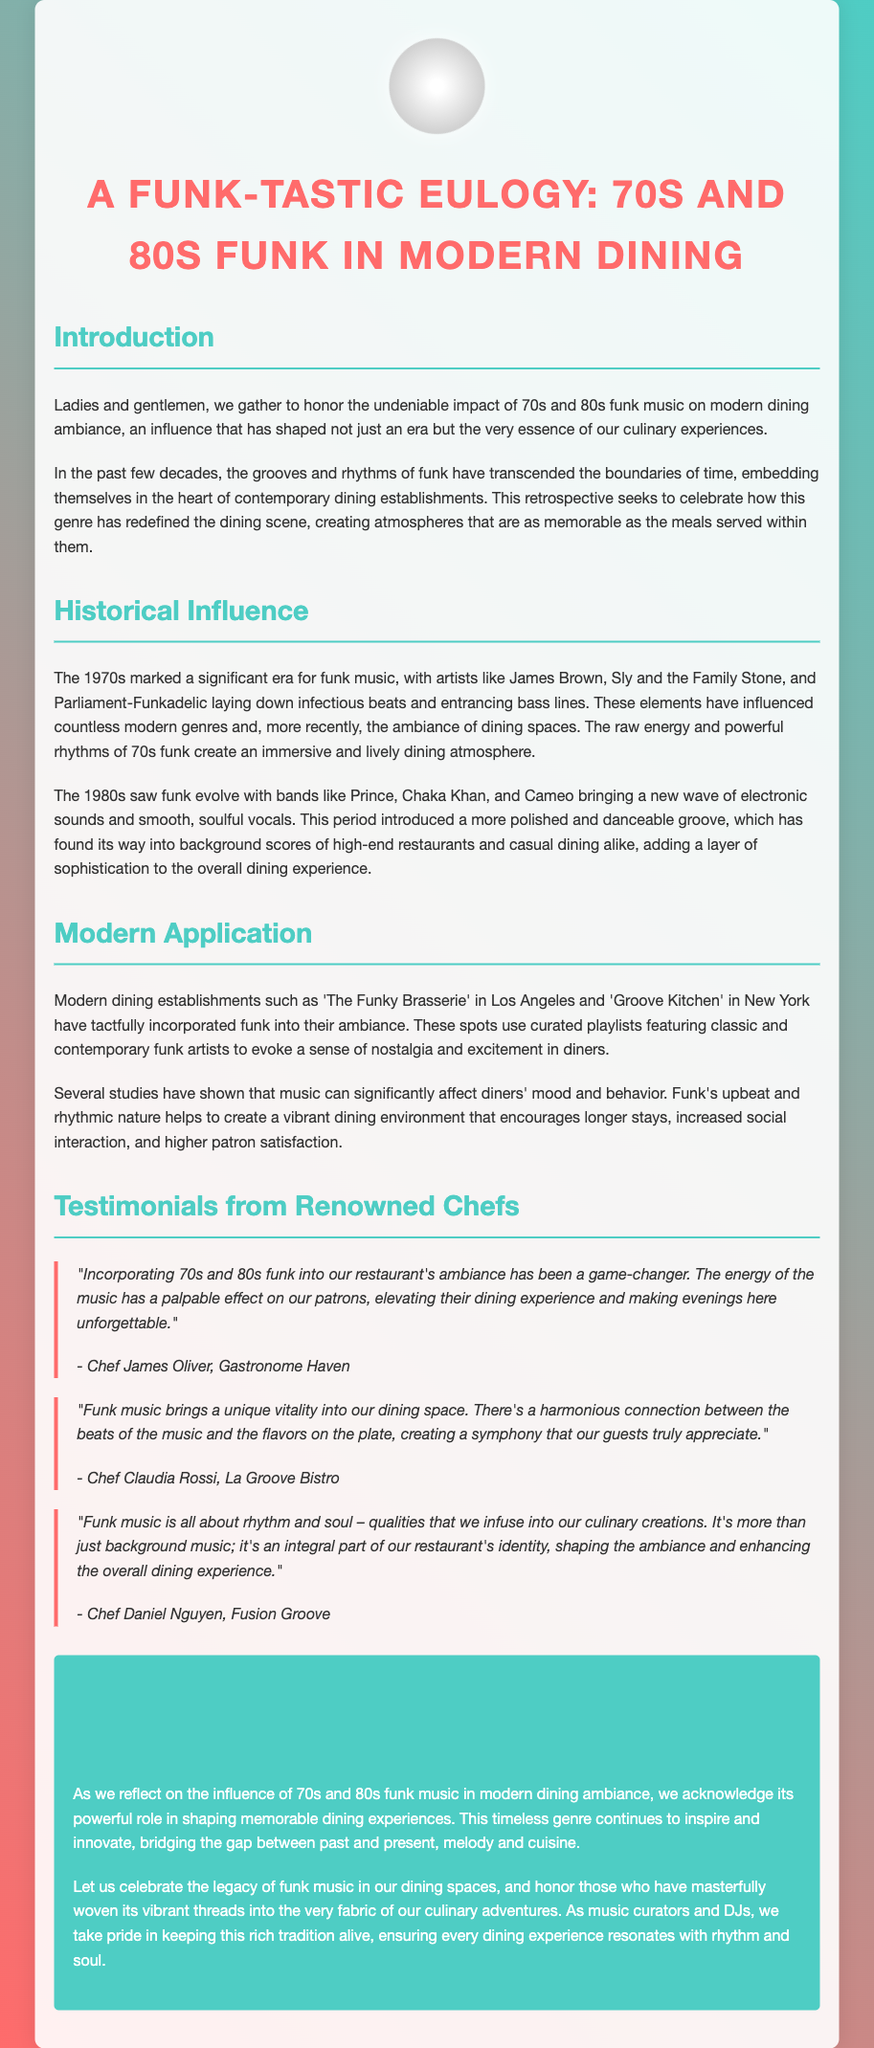What are the two decades discussed in the eulogy? The eulogy discusses the influence of funk music from the 1970s and 1980s.
Answer: 1970s and 1980s Who are some of the artists mentioned from the 70s? The eulogy lists artists like James Brown, Sly and the Family Stone, and Parliament-Funkadelic as influential in the 70s.
Answer: James Brown, Sly and the Family Stone, Parliament-Funkadelic What is the name of a restaurant mentioned that incorporates funk music? The eulogy references 'The Funky Brasserie' in Los Angeles as a restaurant that incorporates funk music into its ambiance.
Answer: The Funky Brasserie Which chef mentioned the effect of music on patrons? Chef James Oliver discusses the effect of integrating funk music into the restaurant's ambiance.
Answer: Chef James Oliver What is one of the moods funk music instills in the dining experience? The eulogy states that funk's upbeat and rhythmic nature helps to create a vibrant dining environment.
Answer: Vibrant What is emphasized about funk music in modern dining according to Chef Daniel Nguyen? Chef Daniel Nguyen emphasizes that funk music shapes the ambiance and enhances the overall dining experience.
Answer: Integral part of identity What does the conclusion celebrate? The conclusion celebrates the legacy of funk music in dining spaces.
Answer: Legacy of funk music What quality of funk music is highlighted by Chef Claudia Rossi? Chef Claudia Rossi highlights the unique vitality that funk music brings to the dining space.
Answer: Vitality 